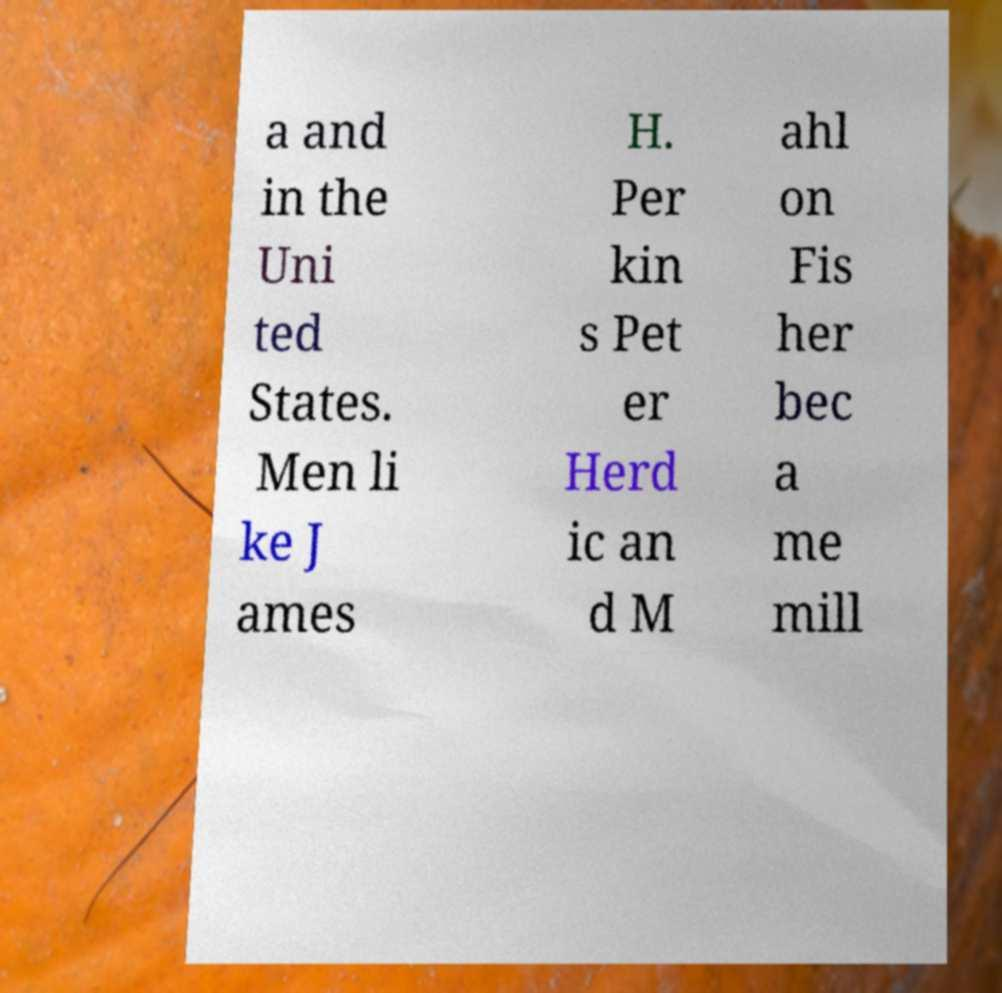I need the written content from this picture converted into text. Can you do that? a and in the Uni ted States. Men li ke J ames H. Per kin s Pet er Herd ic an d M ahl on Fis her bec a me mill 